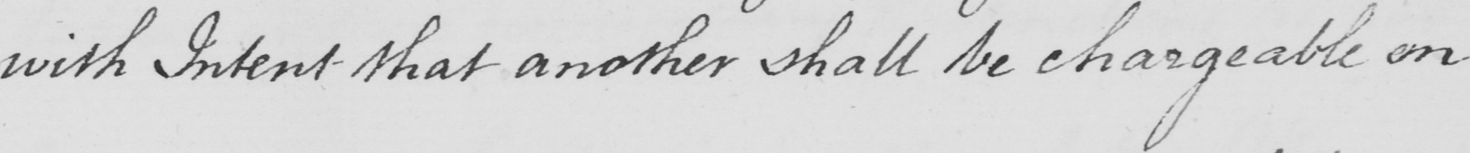Please provide the text content of this handwritten line. with Intent that another shall be chargeable on 